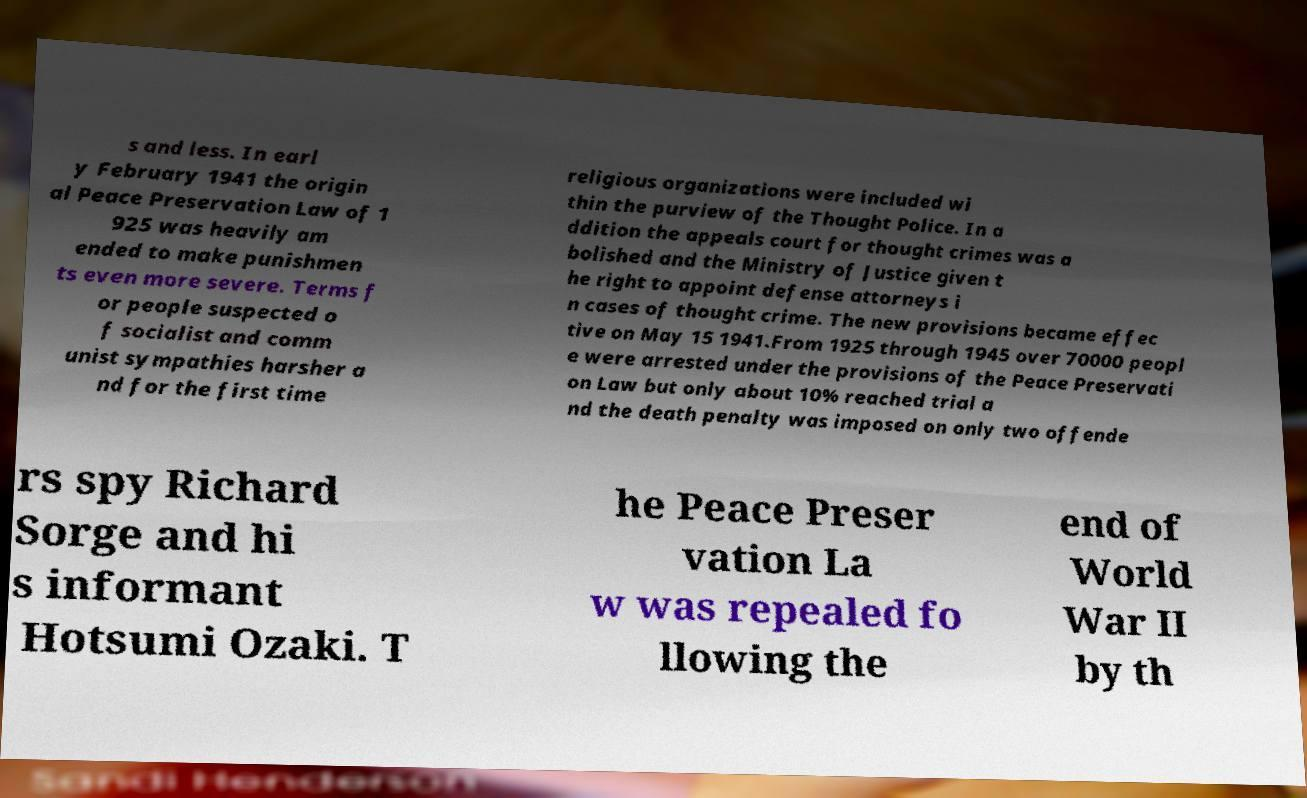What messages or text are displayed in this image? I need them in a readable, typed format. s and less. In earl y February 1941 the origin al Peace Preservation Law of 1 925 was heavily am ended to make punishmen ts even more severe. Terms f or people suspected o f socialist and comm unist sympathies harsher a nd for the first time religious organizations were included wi thin the purview of the Thought Police. In a ddition the appeals court for thought crimes was a bolished and the Ministry of Justice given t he right to appoint defense attorneys i n cases of thought crime. The new provisions became effec tive on May 15 1941.From 1925 through 1945 over 70000 peopl e were arrested under the provisions of the Peace Preservati on Law but only about 10% reached trial a nd the death penalty was imposed on only two offende rs spy Richard Sorge and hi s informant Hotsumi Ozaki. T he Peace Preser vation La w was repealed fo llowing the end of World War II by th 